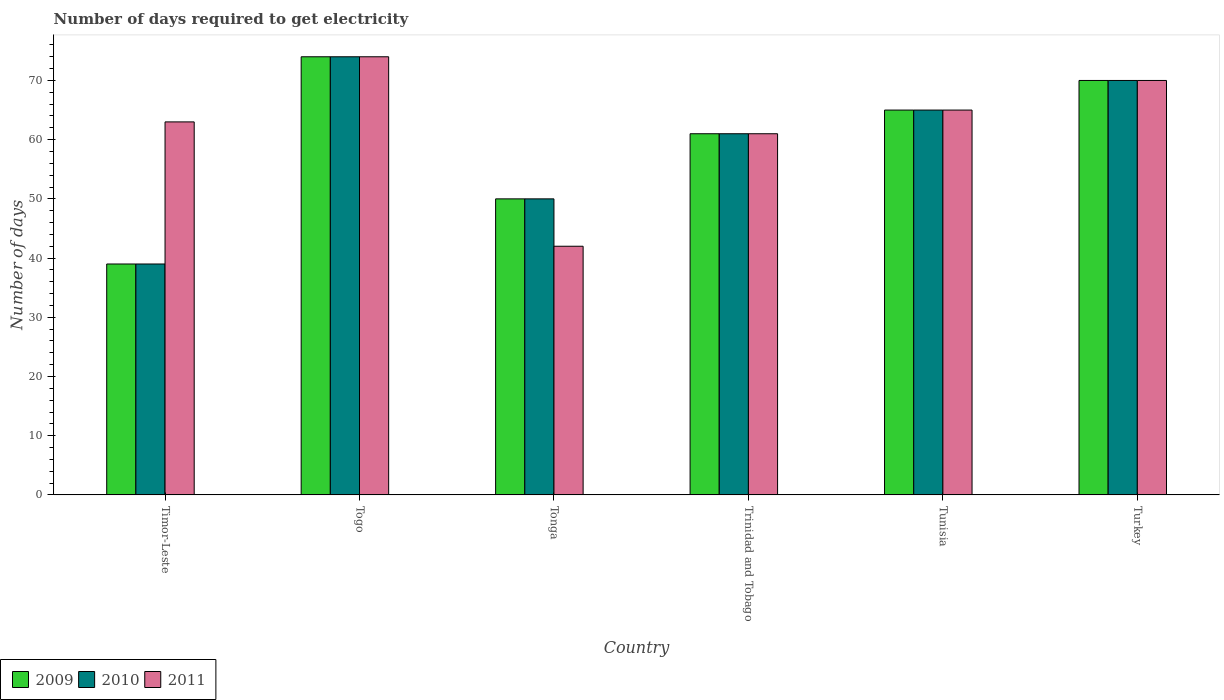How many different coloured bars are there?
Provide a short and direct response. 3. How many groups of bars are there?
Make the answer very short. 6. Are the number of bars per tick equal to the number of legend labels?
Offer a terse response. Yes. Are the number of bars on each tick of the X-axis equal?
Your answer should be very brief. Yes. What is the label of the 5th group of bars from the left?
Make the answer very short. Tunisia. Across all countries, what is the minimum number of days required to get electricity in in 2011?
Offer a terse response. 42. In which country was the number of days required to get electricity in in 2011 maximum?
Ensure brevity in your answer.  Togo. In which country was the number of days required to get electricity in in 2010 minimum?
Provide a succinct answer. Timor-Leste. What is the total number of days required to get electricity in in 2009 in the graph?
Offer a very short reply. 359. What is the difference between the number of days required to get electricity in in 2010 in Tonga and the number of days required to get electricity in in 2011 in Tunisia?
Your response must be concise. -15. What is the average number of days required to get electricity in in 2010 per country?
Your response must be concise. 59.83. In how many countries, is the number of days required to get electricity in in 2009 greater than 56 days?
Provide a short and direct response. 4. What is the ratio of the number of days required to get electricity in in 2009 in Timor-Leste to that in Togo?
Keep it short and to the point. 0.53. Is the number of days required to get electricity in in 2009 in Trinidad and Tobago less than that in Tunisia?
Make the answer very short. Yes. Is the difference between the number of days required to get electricity in in 2010 in Timor-Leste and Turkey greater than the difference between the number of days required to get electricity in in 2009 in Timor-Leste and Turkey?
Ensure brevity in your answer.  No. What is the difference between the highest and the second highest number of days required to get electricity in in 2009?
Your answer should be very brief. -9. What is the difference between the highest and the lowest number of days required to get electricity in in 2009?
Provide a short and direct response. 35. What does the 3rd bar from the right in Tonga represents?
Provide a short and direct response. 2009. How many bars are there?
Make the answer very short. 18. How many countries are there in the graph?
Provide a succinct answer. 6. What is the difference between two consecutive major ticks on the Y-axis?
Provide a short and direct response. 10. Does the graph contain grids?
Provide a short and direct response. No. Where does the legend appear in the graph?
Provide a succinct answer. Bottom left. How are the legend labels stacked?
Keep it short and to the point. Horizontal. What is the title of the graph?
Offer a terse response. Number of days required to get electricity. Does "2014" appear as one of the legend labels in the graph?
Provide a succinct answer. No. What is the label or title of the Y-axis?
Offer a terse response. Number of days. What is the Number of days in 2010 in Timor-Leste?
Your response must be concise. 39. What is the Number of days in 2010 in Togo?
Ensure brevity in your answer.  74. What is the Number of days of 2011 in Togo?
Make the answer very short. 74. What is the Number of days of 2009 in Tonga?
Make the answer very short. 50. What is the Number of days of 2009 in Trinidad and Tobago?
Ensure brevity in your answer.  61. What is the Number of days in 2011 in Trinidad and Tobago?
Provide a succinct answer. 61. What is the Number of days in 2009 in Tunisia?
Ensure brevity in your answer.  65. What is the Number of days of 2010 in Tunisia?
Give a very brief answer. 65. What is the Number of days in 2011 in Tunisia?
Your answer should be compact. 65. What is the Number of days in 2011 in Turkey?
Keep it short and to the point. 70. Across all countries, what is the minimum Number of days in 2009?
Your answer should be very brief. 39. Across all countries, what is the minimum Number of days in 2010?
Make the answer very short. 39. What is the total Number of days of 2009 in the graph?
Ensure brevity in your answer.  359. What is the total Number of days in 2010 in the graph?
Provide a succinct answer. 359. What is the total Number of days in 2011 in the graph?
Provide a succinct answer. 375. What is the difference between the Number of days in 2009 in Timor-Leste and that in Togo?
Your response must be concise. -35. What is the difference between the Number of days of 2010 in Timor-Leste and that in Togo?
Provide a succinct answer. -35. What is the difference between the Number of days in 2011 in Timor-Leste and that in Togo?
Your answer should be very brief. -11. What is the difference between the Number of days of 2011 in Timor-Leste and that in Trinidad and Tobago?
Offer a very short reply. 2. What is the difference between the Number of days in 2009 in Timor-Leste and that in Tunisia?
Make the answer very short. -26. What is the difference between the Number of days of 2010 in Timor-Leste and that in Tunisia?
Provide a short and direct response. -26. What is the difference between the Number of days in 2011 in Timor-Leste and that in Tunisia?
Make the answer very short. -2. What is the difference between the Number of days in 2009 in Timor-Leste and that in Turkey?
Offer a terse response. -31. What is the difference between the Number of days of 2010 in Timor-Leste and that in Turkey?
Provide a succinct answer. -31. What is the difference between the Number of days of 2009 in Togo and that in Trinidad and Tobago?
Your response must be concise. 13. What is the difference between the Number of days of 2010 in Togo and that in Trinidad and Tobago?
Offer a terse response. 13. What is the difference between the Number of days of 2010 in Togo and that in Tunisia?
Offer a terse response. 9. What is the difference between the Number of days in 2011 in Togo and that in Tunisia?
Your response must be concise. 9. What is the difference between the Number of days of 2009 in Togo and that in Turkey?
Provide a short and direct response. 4. What is the difference between the Number of days of 2010 in Tonga and that in Trinidad and Tobago?
Offer a very short reply. -11. What is the difference between the Number of days in 2011 in Tonga and that in Trinidad and Tobago?
Provide a succinct answer. -19. What is the difference between the Number of days of 2010 in Tonga and that in Tunisia?
Offer a very short reply. -15. What is the difference between the Number of days in 2011 in Tonga and that in Tunisia?
Keep it short and to the point. -23. What is the difference between the Number of days of 2009 in Tonga and that in Turkey?
Give a very brief answer. -20. What is the difference between the Number of days in 2010 in Tonga and that in Turkey?
Provide a short and direct response. -20. What is the difference between the Number of days in 2011 in Tonga and that in Turkey?
Your answer should be very brief. -28. What is the difference between the Number of days of 2009 in Trinidad and Tobago and that in Tunisia?
Offer a very short reply. -4. What is the difference between the Number of days of 2011 in Trinidad and Tobago and that in Tunisia?
Your answer should be compact. -4. What is the difference between the Number of days of 2009 in Trinidad and Tobago and that in Turkey?
Provide a short and direct response. -9. What is the difference between the Number of days of 2010 in Trinidad and Tobago and that in Turkey?
Offer a very short reply. -9. What is the difference between the Number of days in 2009 in Tunisia and that in Turkey?
Provide a succinct answer. -5. What is the difference between the Number of days of 2010 in Tunisia and that in Turkey?
Your answer should be compact. -5. What is the difference between the Number of days in 2009 in Timor-Leste and the Number of days in 2010 in Togo?
Provide a succinct answer. -35. What is the difference between the Number of days of 2009 in Timor-Leste and the Number of days of 2011 in Togo?
Keep it short and to the point. -35. What is the difference between the Number of days in 2010 in Timor-Leste and the Number of days in 2011 in Togo?
Ensure brevity in your answer.  -35. What is the difference between the Number of days of 2009 in Timor-Leste and the Number of days of 2010 in Tonga?
Ensure brevity in your answer.  -11. What is the difference between the Number of days of 2010 in Timor-Leste and the Number of days of 2011 in Tonga?
Offer a terse response. -3. What is the difference between the Number of days in 2009 in Timor-Leste and the Number of days in 2010 in Trinidad and Tobago?
Provide a succinct answer. -22. What is the difference between the Number of days in 2010 in Timor-Leste and the Number of days in 2011 in Trinidad and Tobago?
Your response must be concise. -22. What is the difference between the Number of days in 2009 in Timor-Leste and the Number of days in 2010 in Tunisia?
Provide a short and direct response. -26. What is the difference between the Number of days in 2009 in Timor-Leste and the Number of days in 2010 in Turkey?
Keep it short and to the point. -31. What is the difference between the Number of days in 2009 in Timor-Leste and the Number of days in 2011 in Turkey?
Your answer should be compact. -31. What is the difference between the Number of days of 2010 in Timor-Leste and the Number of days of 2011 in Turkey?
Make the answer very short. -31. What is the difference between the Number of days in 2009 in Togo and the Number of days in 2010 in Tonga?
Your answer should be very brief. 24. What is the difference between the Number of days in 2009 in Togo and the Number of days in 2011 in Tonga?
Offer a very short reply. 32. What is the difference between the Number of days in 2010 in Togo and the Number of days in 2011 in Tonga?
Provide a succinct answer. 32. What is the difference between the Number of days in 2009 in Togo and the Number of days in 2010 in Trinidad and Tobago?
Provide a succinct answer. 13. What is the difference between the Number of days in 2009 in Togo and the Number of days in 2011 in Trinidad and Tobago?
Make the answer very short. 13. What is the difference between the Number of days of 2010 in Togo and the Number of days of 2011 in Tunisia?
Your response must be concise. 9. What is the difference between the Number of days in 2009 in Togo and the Number of days in 2010 in Turkey?
Keep it short and to the point. 4. What is the difference between the Number of days of 2009 in Togo and the Number of days of 2011 in Turkey?
Offer a very short reply. 4. What is the difference between the Number of days in 2010 in Tonga and the Number of days in 2011 in Trinidad and Tobago?
Keep it short and to the point. -11. What is the difference between the Number of days in 2009 in Tonga and the Number of days in 2010 in Tunisia?
Offer a very short reply. -15. What is the difference between the Number of days of 2009 in Tonga and the Number of days of 2011 in Tunisia?
Give a very brief answer. -15. What is the difference between the Number of days in 2009 in Tonga and the Number of days in 2010 in Turkey?
Provide a succinct answer. -20. What is the difference between the Number of days of 2009 in Tonga and the Number of days of 2011 in Turkey?
Your response must be concise. -20. What is the difference between the Number of days in 2009 in Trinidad and Tobago and the Number of days in 2011 in Tunisia?
Offer a very short reply. -4. What is the difference between the Number of days in 2010 in Trinidad and Tobago and the Number of days in 2011 in Tunisia?
Your answer should be very brief. -4. What is the difference between the Number of days of 2009 in Trinidad and Tobago and the Number of days of 2010 in Turkey?
Ensure brevity in your answer.  -9. What is the difference between the Number of days of 2009 in Trinidad and Tobago and the Number of days of 2011 in Turkey?
Your answer should be compact. -9. What is the difference between the Number of days in 2010 in Trinidad and Tobago and the Number of days in 2011 in Turkey?
Provide a succinct answer. -9. What is the difference between the Number of days of 2009 in Tunisia and the Number of days of 2011 in Turkey?
Provide a succinct answer. -5. What is the difference between the Number of days in 2010 in Tunisia and the Number of days in 2011 in Turkey?
Your answer should be very brief. -5. What is the average Number of days of 2009 per country?
Your answer should be very brief. 59.83. What is the average Number of days of 2010 per country?
Your answer should be very brief. 59.83. What is the average Number of days in 2011 per country?
Your response must be concise. 62.5. What is the difference between the Number of days in 2009 and Number of days in 2010 in Timor-Leste?
Provide a short and direct response. 0. What is the difference between the Number of days of 2009 and Number of days of 2011 in Timor-Leste?
Make the answer very short. -24. What is the difference between the Number of days in 2010 and Number of days in 2011 in Togo?
Your answer should be very brief. 0. What is the difference between the Number of days in 2009 and Number of days in 2011 in Tonga?
Offer a terse response. 8. What is the difference between the Number of days of 2010 and Number of days of 2011 in Tonga?
Ensure brevity in your answer.  8. What is the difference between the Number of days in 2009 and Number of days in 2010 in Trinidad and Tobago?
Keep it short and to the point. 0. What is the difference between the Number of days of 2010 and Number of days of 2011 in Tunisia?
Provide a succinct answer. 0. What is the difference between the Number of days in 2010 and Number of days in 2011 in Turkey?
Provide a short and direct response. 0. What is the ratio of the Number of days in 2009 in Timor-Leste to that in Togo?
Ensure brevity in your answer.  0.53. What is the ratio of the Number of days of 2010 in Timor-Leste to that in Togo?
Your answer should be very brief. 0.53. What is the ratio of the Number of days of 2011 in Timor-Leste to that in Togo?
Keep it short and to the point. 0.85. What is the ratio of the Number of days of 2009 in Timor-Leste to that in Tonga?
Ensure brevity in your answer.  0.78. What is the ratio of the Number of days in 2010 in Timor-Leste to that in Tonga?
Offer a terse response. 0.78. What is the ratio of the Number of days of 2011 in Timor-Leste to that in Tonga?
Offer a terse response. 1.5. What is the ratio of the Number of days of 2009 in Timor-Leste to that in Trinidad and Tobago?
Your answer should be very brief. 0.64. What is the ratio of the Number of days in 2010 in Timor-Leste to that in Trinidad and Tobago?
Your answer should be very brief. 0.64. What is the ratio of the Number of days of 2011 in Timor-Leste to that in Trinidad and Tobago?
Your answer should be very brief. 1.03. What is the ratio of the Number of days of 2010 in Timor-Leste to that in Tunisia?
Your answer should be compact. 0.6. What is the ratio of the Number of days of 2011 in Timor-Leste to that in Tunisia?
Give a very brief answer. 0.97. What is the ratio of the Number of days in 2009 in Timor-Leste to that in Turkey?
Make the answer very short. 0.56. What is the ratio of the Number of days in 2010 in Timor-Leste to that in Turkey?
Offer a terse response. 0.56. What is the ratio of the Number of days of 2009 in Togo to that in Tonga?
Offer a terse response. 1.48. What is the ratio of the Number of days of 2010 in Togo to that in Tonga?
Keep it short and to the point. 1.48. What is the ratio of the Number of days of 2011 in Togo to that in Tonga?
Your answer should be compact. 1.76. What is the ratio of the Number of days in 2009 in Togo to that in Trinidad and Tobago?
Ensure brevity in your answer.  1.21. What is the ratio of the Number of days in 2010 in Togo to that in Trinidad and Tobago?
Make the answer very short. 1.21. What is the ratio of the Number of days of 2011 in Togo to that in Trinidad and Tobago?
Offer a very short reply. 1.21. What is the ratio of the Number of days in 2009 in Togo to that in Tunisia?
Offer a terse response. 1.14. What is the ratio of the Number of days in 2010 in Togo to that in Tunisia?
Give a very brief answer. 1.14. What is the ratio of the Number of days of 2011 in Togo to that in Tunisia?
Make the answer very short. 1.14. What is the ratio of the Number of days in 2009 in Togo to that in Turkey?
Ensure brevity in your answer.  1.06. What is the ratio of the Number of days in 2010 in Togo to that in Turkey?
Ensure brevity in your answer.  1.06. What is the ratio of the Number of days in 2011 in Togo to that in Turkey?
Provide a short and direct response. 1.06. What is the ratio of the Number of days in 2009 in Tonga to that in Trinidad and Tobago?
Provide a succinct answer. 0.82. What is the ratio of the Number of days of 2010 in Tonga to that in Trinidad and Tobago?
Give a very brief answer. 0.82. What is the ratio of the Number of days in 2011 in Tonga to that in Trinidad and Tobago?
Keep it short and to the point. 0.69. What is the ratio of the Number of days in 2009 in Tonga to that in Tunisia?
Your answer should be very brief. 0.77. What is the ratio of the Number of days of 2010 in Tonga to that in Tunisia?
Ensure brevity in your answer.  0.77. What is the ratio of the Number of days of 2011 in Tonga to that in Tunisia?
Provide a succinct answer. 0.65. What is the ratio of the Number of days of 2009 in Tonga to that in Turkey?
Offer a terse response. 0.71. What is the ratio of the Number of days in 2010 in Tonga to that in Turkey?
Your answer should be compact. 0.71. What is the ratio of the Number of days of 2011 in Tonga to that in Turkey?
Provide a short and direct response. 0.6. What is the ratio of the Number of days in 2009 in Trinidad and Tobago to that in Tunisia?
Provide a succinct answer. 0.94. What is the ratio of the Number of days in 2010 in Trinidad and Tobago to that in Tunisia?
Provide a short and direct response. 0.94. What is the ratio of the Number of days of 2011 in Trinidad and Tobago to that in Tunisia?
Your answer should be very brief. 0.94. What is the ratio of the Number of days of 2009 in Trinidad and Tobago to that in Turkey?
Offer a terse response. 0.87. What is the ratio of the Number of days of 2010 in Trinidad and Tobago to that in Turkey?
Ensure brevity in your answer.  0.87. What is the ratio of the Number of days of 2011 in Trinidad and Tobago to that in Turkey?
Make the answer very short. 0.87. What is the ratio of the Number of days in 2010 in Tunisia to that in Turkey?
Provide a succinct answer. 0.93. What is the difference between the highest and the second highest Number of days in 2009?
Keep it short and to the point. 4. What is the difference between the highest and the lowest Number of days of 2009?
Ensure brevity in your answer.  35. What is the difference between the highest and the lowest Number of days of 2010?
Make the answer very short. 35. 